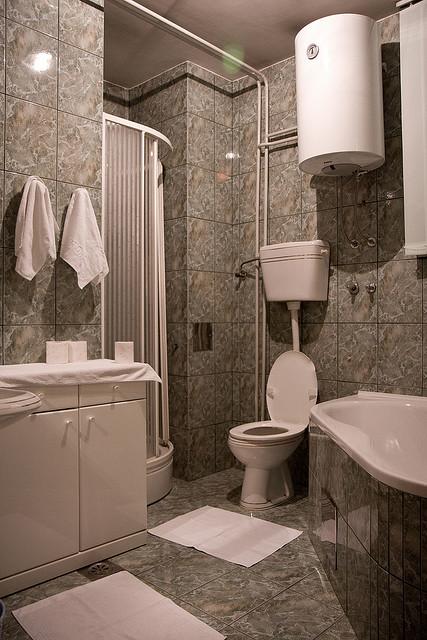Are there towels on the ground?
Be succinct. Yes. Is this picture in color?
Keep it brief. Yes. Is there a shower in this bathroom?
Keep it brief. Yes. 